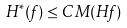<formula> <loc_0><loc_0><loc_500><loc_500>H ^ { * } ( f ) \leq C \, M ( H f )</formula> 